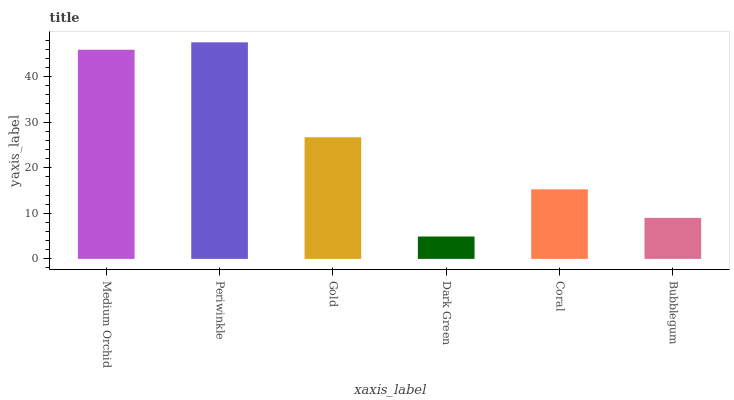Is Dark Green the minimum?
Answer yes or no. Yes. Is Periwinkle the maximum?
Answer yes or no. Yes. Is Gold the minimum?
Answer yes or no. No. Is Gold the maximum?
Answer yes or no. No. Is Periwinkle greater than Gold?
Answer yes or no. Yes. Is Gold less than Periwinkle?
Answer yes or no. Yes. Is Gold greater than Periwinkle?
Answer yes or no. No. Is Periwinkle less than Gold?
Answer yes or no. No. Is Gold the high median?
Answer yes or no. Yes. Is Coral the low median?
Answer yes or no. Yes. Is Bubblegum the high median?
Answer yes or no. No. Is Gold the low median?
Answer yes or no. No. 